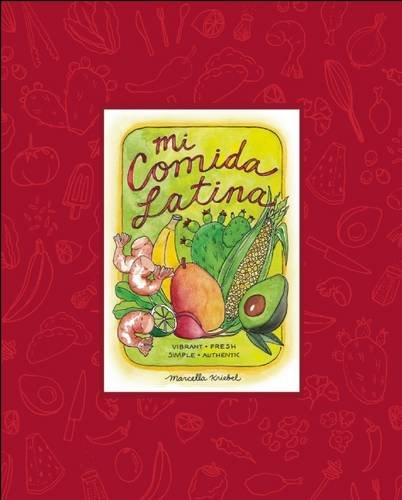Is this a recipe book? Yes, indeed it is a recipe book. 'Mi Comida Latina' offers a collection of authentic, simple, and delicious recipes inspired by Latin American cuisine, adding a vibrant touch to any kitchen library. 